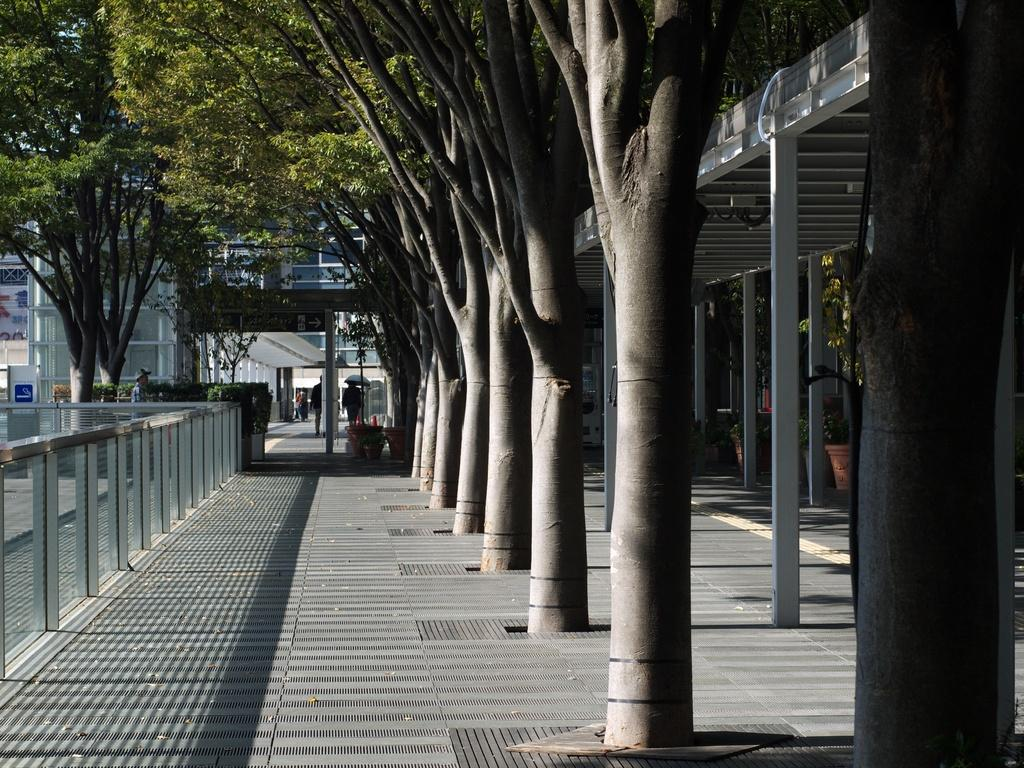What type of vegetation can be seen in the right corner of the image? There are trees in the right corner of the image. What type of barrier is present in the left corner of the image? There is a fence in the left corner of the image. What can be seen in the background of the image? There are trees and buildings in the background of the image. Are there any people visible in the image? Yes, there are people in the background of the image. How many dinosaurs are present in the image? There are no dinosaurs present in the image. What type of waste can be seen in the image? There is no waste present in the image. 